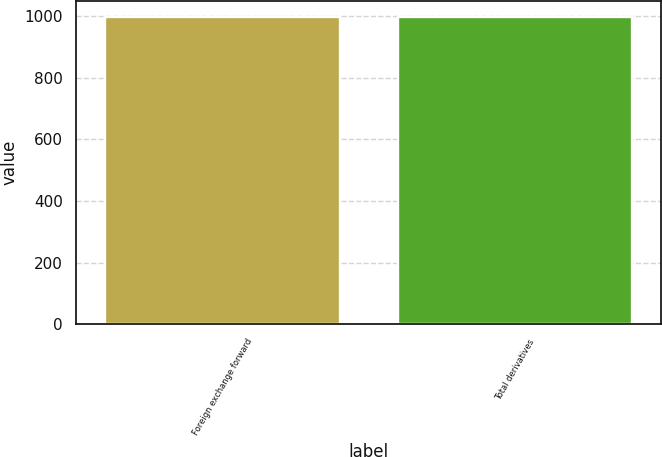Convert chart. <chart><loc_0><loc_0><loc_500><loc_500><bar_chart><fcel>Foreign exchange forward<fcel>Total derivatives<nl><fcel>998<fcel>998.1<nl></chart> 